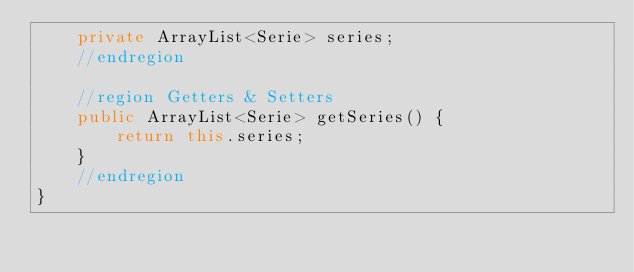Convert code to text. <code><loc_0><loc_0><loc_500><loc_500><_Java_>    private ArrayList<Serie> series;
    //endregion

    //region Getters & Setters
    public ArrayList<Serie> getSeries() {
        return this.series;
    }
    //endregion
}</code> 